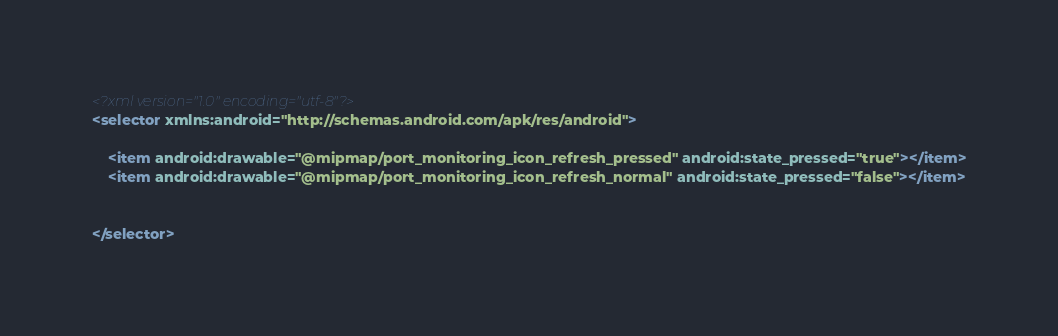Convert code to text. <code><loc_0><loc_0><loc_500><loc_500><_XML_><?xml version="1.0" encoding="utf-8"?>
<selector xmlns:android="http://schemas.android.com/apk/res/android">

    <item android:drawable="@mipmap/port_monitoring_icon_refresh_pressed" android:state_pressed="true"></item>
    <item android:drawable="@mipmap/port_monitoring_icon_refresh_normal" android:state_pressed="false"></item>


</selector></code> 